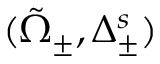Convert formula to latex. <formula><loc_0><loc_0><loc_500><loc_500>( _ { \pm } , \Delta _ { \pm } ^ { s } )</formula> 